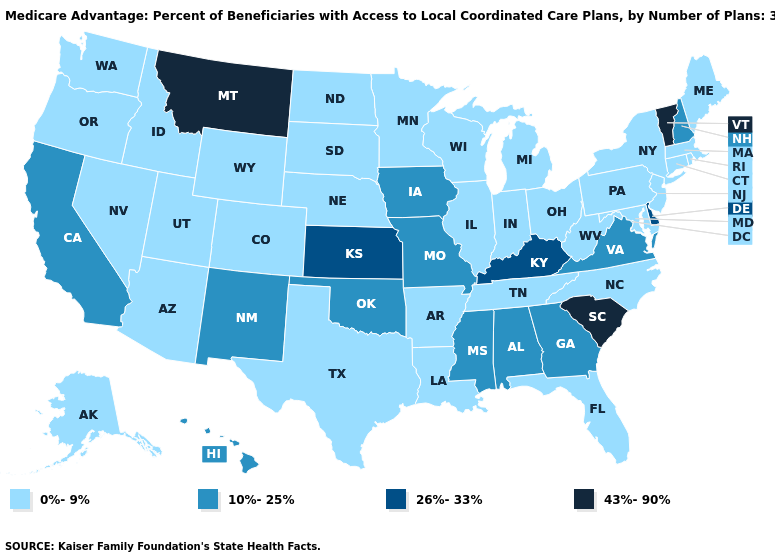Which states have the lowest value in the West?
Quick response, please. Colorado, Idaho, Nevada, Oregon, Alaska, Utah, Washington, Wyoming, Arizona. What is the value of South Dakota?
Give a very brief answer. 0%-9%. Name the states that have a value in the range 0%-9%?
Write a very short answer. Colorado, Connecticut, Florida, Idaho, Illinois, Indiana, Louisiana, Massachusetts, Maryland, Maine, Michigan, Minnesota, North Carolina, North Dakota, Nebraska, New Jersey, Nevada, New York, Ohio, Oregon, Pennsylvania, Rhode Island, South Dakota, Alaska, Tennessee, Texas, Utah, Washington, Wisconsin, West Virginia, Wyoming, Arkansas, Arizona. What is the value of Oklahoma?
Keep it brief. 10%-25%. Does Iowa have a higher value than Wisconsin?
Be succinct. Yes. Name the states that have a value in the range 26%-33%?
Answer briefly. Delaware, Kansas, Kentucky. Does Kansas have the same value as Delaware?
Concise answer only. Yes. Which states have the lowest value in the Northeast?
Keep it brief. Connecticut, Massachusetts, Maine, New Jersey, New York, Pennsylvania, Rhode Island. How many symbols are there in the legend?
Give a very brief answer. 4. What is the lowest value in the South?
Be succinct. 0%-9%. What is the value of North Carolina?
Quick response, please. 0%-9%. Which states have the lowest value in the West?
Short answer required. Colorado, Idaho, Nevada, Oregon, Alaska, Utah, Washington, Wyoming, Arizona. Which states have the lowest value in the South?
Give a very brief answer. Florida, Louisiana, Maryland, North Carolina, Tennessee, Texas, West Virginia, Arkansas. 